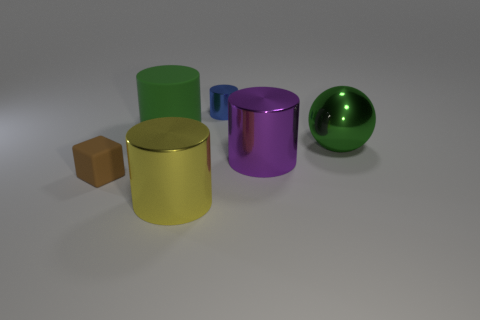Add 4 big green shiny things. How many objects exist? 10 Subtract all balls. How many objects are left? 5 Subtract all metal spheres. Subtract all shiny cylinders. How many objects are left? 2 Add 1 green metallic spheres. How many green metallic spheres are left? 2 Add 5 large green rubber things. How many large green rubber things exist? 6 Subtract 0 red cubes. How many objects are left? 6 